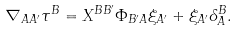<formula> <loc_0><loc_0><loc_500><loc_500>\nabla _ { A A ^ { \prime } } \tau ^ { B } = X ^ { B B ^ { \prime } } \Phi _ { B ^ { \prime } A } \xi _ { A ^ { \prime } } + \xi _ { A ^ { \prime } } \delta ^ { B } _ { A } .</formula> 